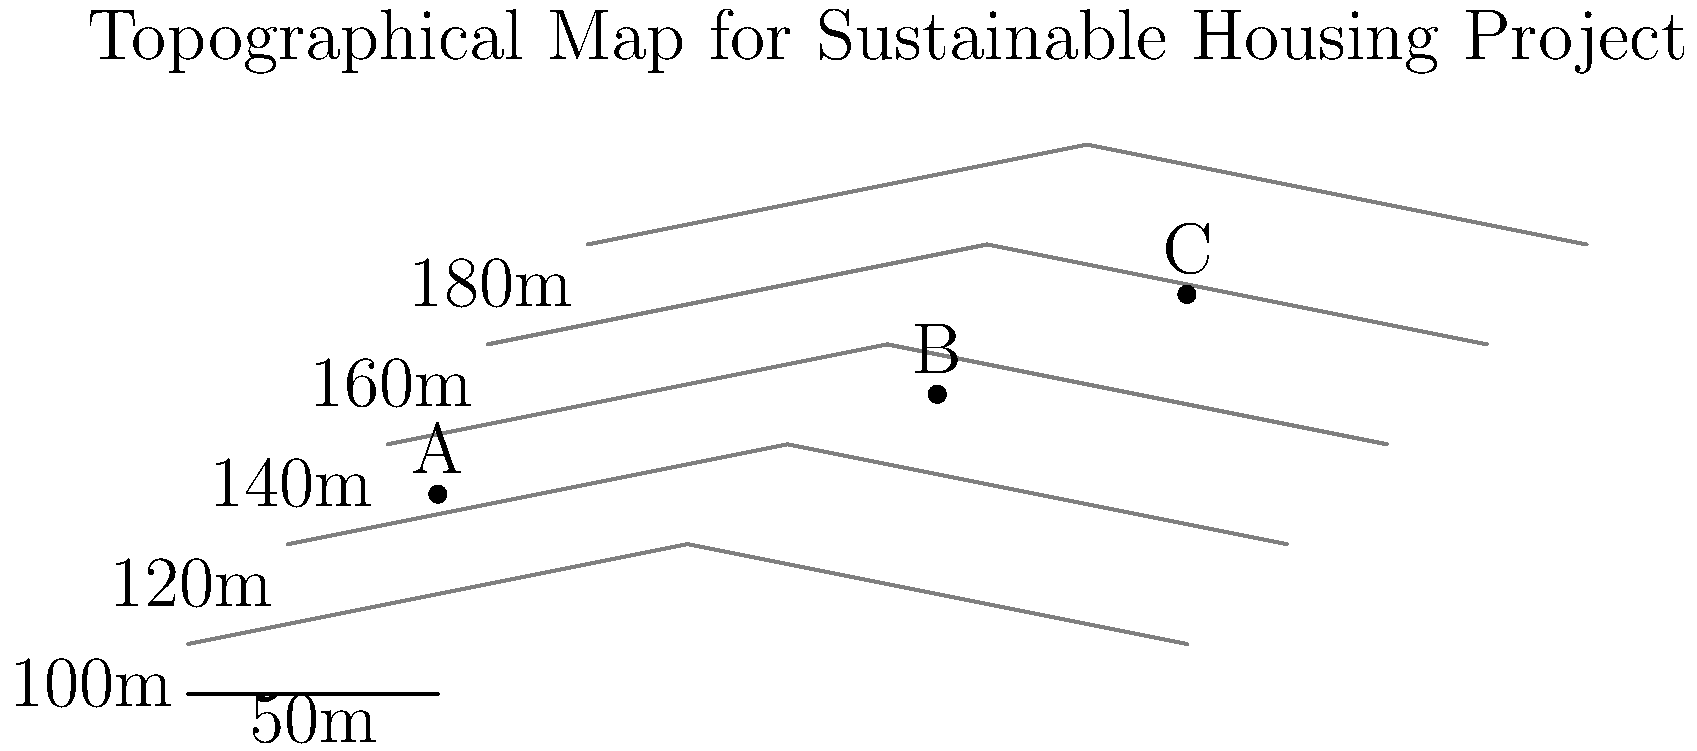As the director of a non-profit organization focused on creating job opportunities and providing training for single mothers, you are tasked with selecting the optimal location for a sustainable housing project. Given the topographical map above, which site (A, B, or C) would be most suitable for the project, considering factors such as accessibility, flood risk, and construction costs? To determine the most suitable site for the sustainable housing project, we need to analyze each location based on the following factors:

1. Elevation and flood risk:
   - Site A: Located at approximately 125m elevation
   - Site B: Located at approximately 145m elevation
   - Site C: Located at approximately 165m elevation
   Higher elevation generally means lower flood risk.

2. Slope and construction costs:
   - Site A: Located in an area with wider spacing between contour lines, indicating a gentler slope
   - Site B: Moderate spacing between contour lines, indicating a moderate slope
   - Site C: Closer spacing between contour lines, indicating a steeper slope
   Gentler slopes are typically easier and less expensive to build on.

3. Accessibility:
   - Site A: Closest to the lower elevation areas, potentially easier access to existing infrastructure
   - Site B: Moderate distance from lower elevations
   - Site C: Furthest from lower elevations, potentially more difficult to access

Step-by-step analysis:
1. Flood risk: C > B > A (C has the lowest risk)
2. Construction costs: A > B > C (A would be the least expensive)
3. Accessibility: A > B > C (A is the most accessible)

Considering these factors, Site B offers the best compromise:
- It has a lower flood risk than Site A
- It has more moderate construction costs than Site C
- It provides better accessibility than Site C

Additionally, Site B's central location on the map could potentially serve a wider area of the community, which aligns with the organization's goal of creating job opportunities and providing training for single mothers.
Answer: Site B 